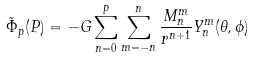Convert formula to latex. <formula><loc_0><loc_0><loc_500><loc_500>\tilde { \Phi } _ { p } ( P ) = - G \sum _ { n = 0 } ^ { p } \sum _ { m = - n } ^ { n } \frac { M ^ { m } _ { n } } { r ^ { n + 1 } } Y ^ { m } _ { n } ( \theta , \phi )</formula> 